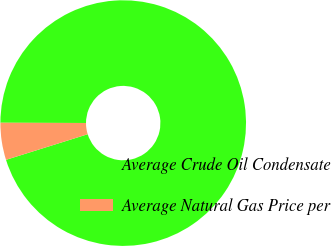Convert chart. <chart><loc_0><loc_0><loc_500><loc_500><pie_chart><fcel>Average Crude Oil Condensate<fcel>Average Natural Gas Price per<nl><fcel>95.12%<fcel>4.88%<nl></chart> 